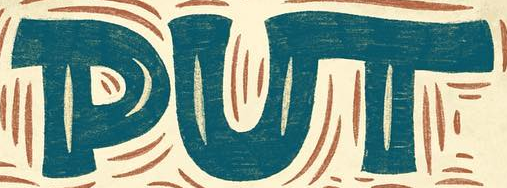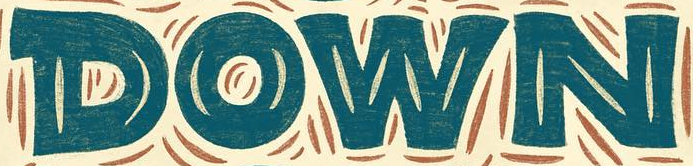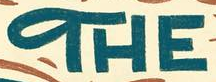Transcribe the words shown in these images in order, separated by a semicolon. PUT; DOWN; THE 